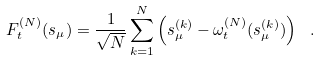Convert formula to latex. <formula><loc_0><loc_0><loc_500><loc_500>F _ { t } ^ { ( N ) } ( s _ { \mu } ) = \frac { 1 } { \sqrt { N } } \sum _ { k = 1 } ^ { N } \left ( s _ { \mu } ^ { ( k ) } - \omega ^ { ( N ) } _ { t } ( s _ { \mu } ^ { ( k ) } ) \right ) \ .</formula> 